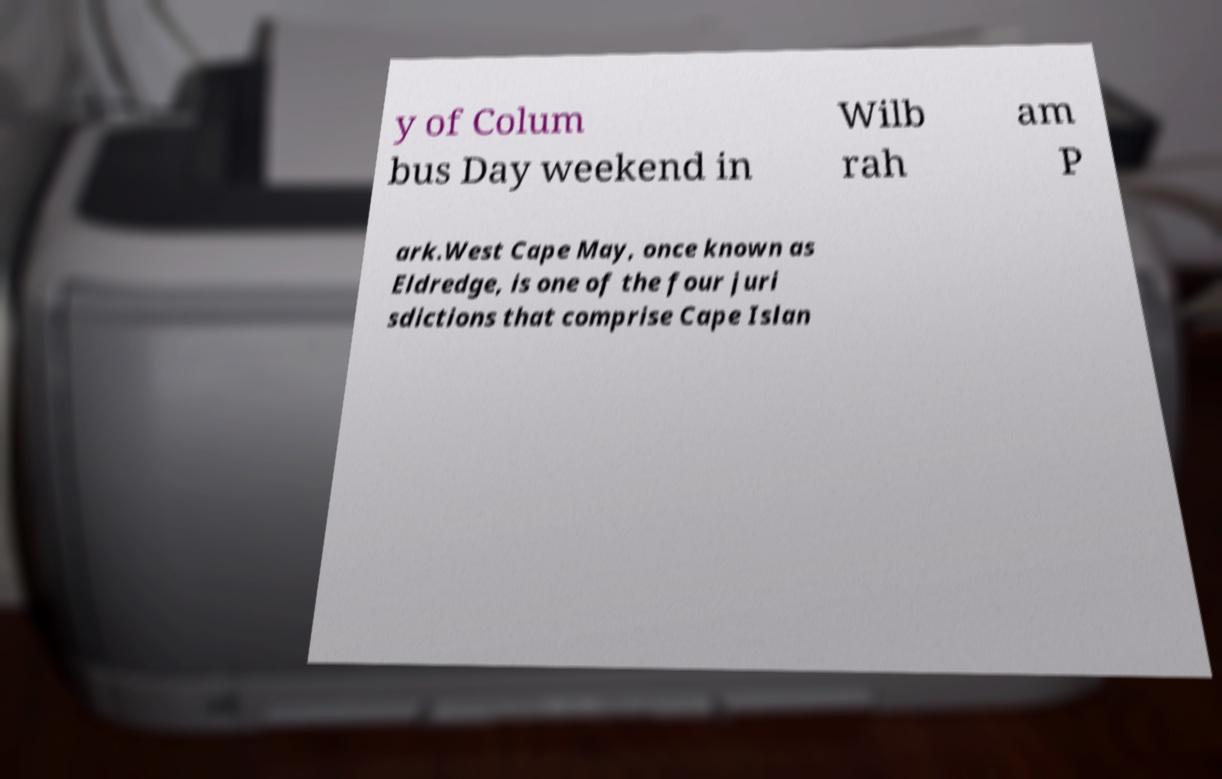I need the written content from this picture converted into text. Can you do that? y of Colum bus Day weekend in Wilb rah am P ark.West Cape May, once known as Eldredge, is one of the four juri sdictions that comprise Cape Islan 